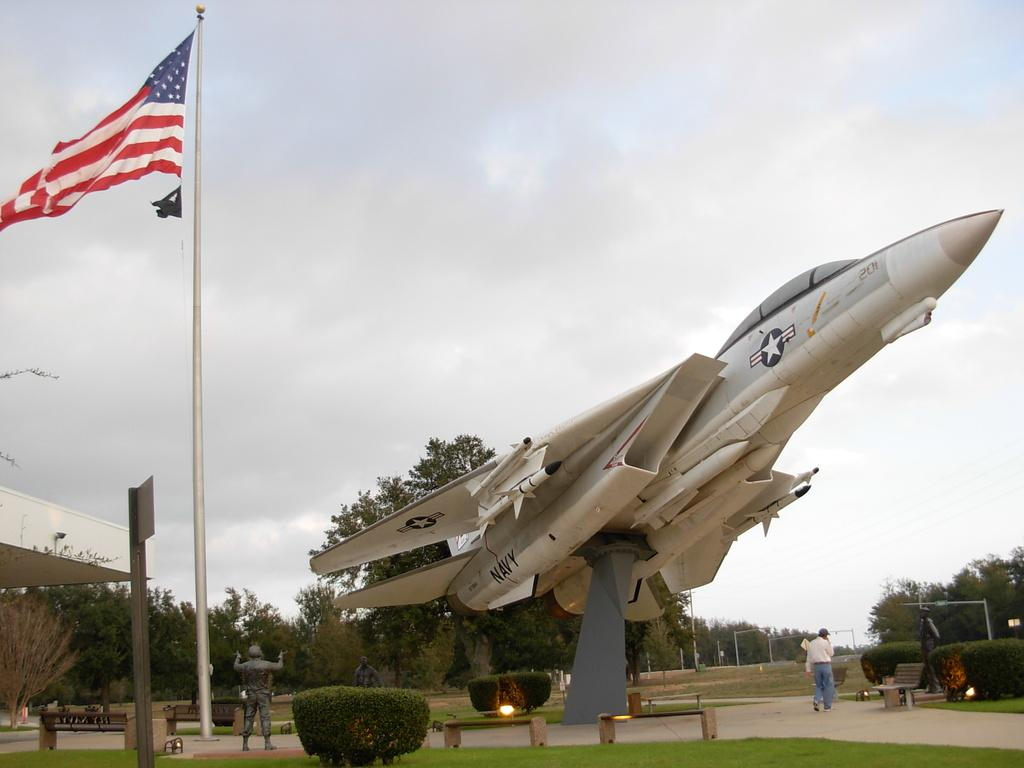How many people are in the image? There are people in the image, but the exact number is not specified. What is the main subject in the image? The main subject in the image is an airplane. What is attached to the pole in the image? A flag is attached to the pole in the image. What type of vegetation is present in the image? There are plants and grass in the image. What type of lighting is visible in the image? There are lights in the image. What can be seen in the background of the image? Trees, rods, poles, and sky are visible in the background of the image. What type of apparel is the elbow wearing in the image? There is no mention of an elbow or apparel in the image. 